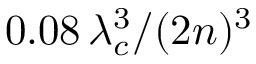<formula> <loc_0><loc_0><loc_500><loc_500>0 . 0 8 \, \lambda _ { c } ^ { 3 } / ( 2 n ) ^ { 3 }</formula> 